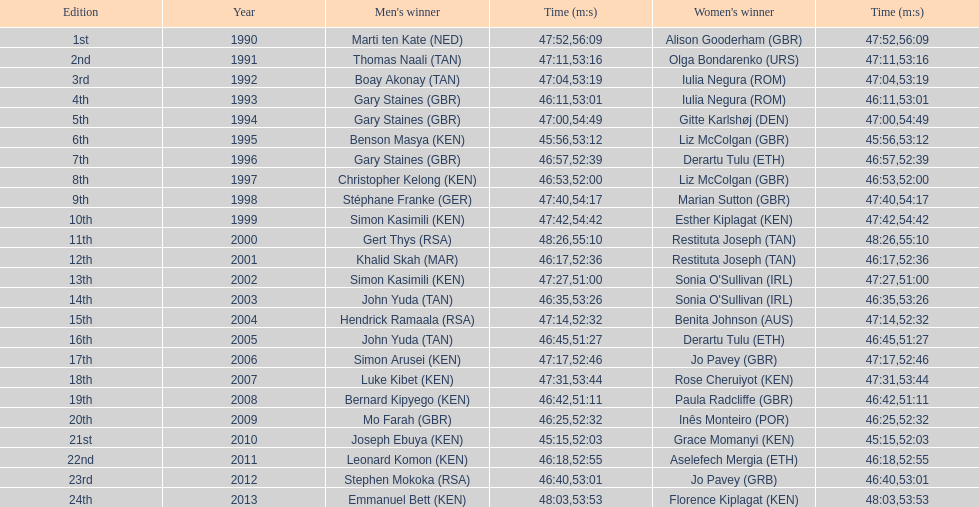The other women's winner with the same finish time as jo pavey in 2012 Iulia Negura. 